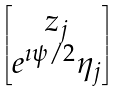Convert formula to latex. <formula><loc_0><loc_0><loc_500><loc_500>\begin{bmatrix} z _ { j } \\ e ^ { \imath \psi / 2 } \eta _ { j } \end{bmatrix}</formula> 